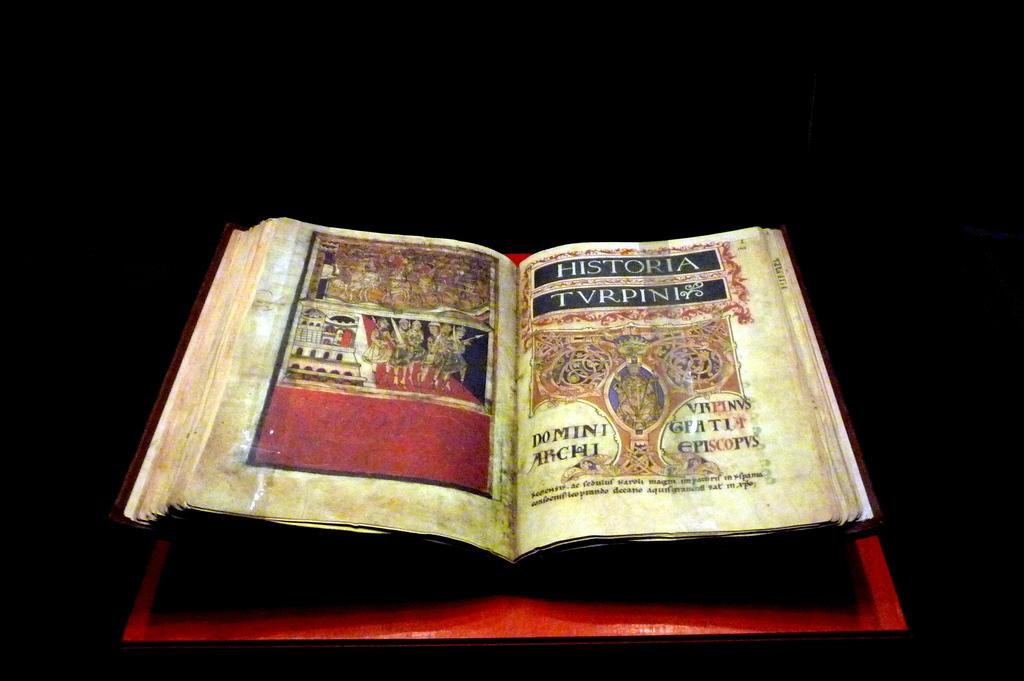What is the main subject of the image? The main subject of the image is a photograph of a book. Where is the book placed in the image? The book is placed on a red table top. What is the color of the background in the image? The background in the image is black. What grade is the book about in the image? The image does not provide information about the grade or subject matter of the book. Is there a hammer visible in the image? No, there is no hammer present in the image. 